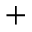<formula> <loc_0><loc_0><loc_500><loc_500>+</formula> 